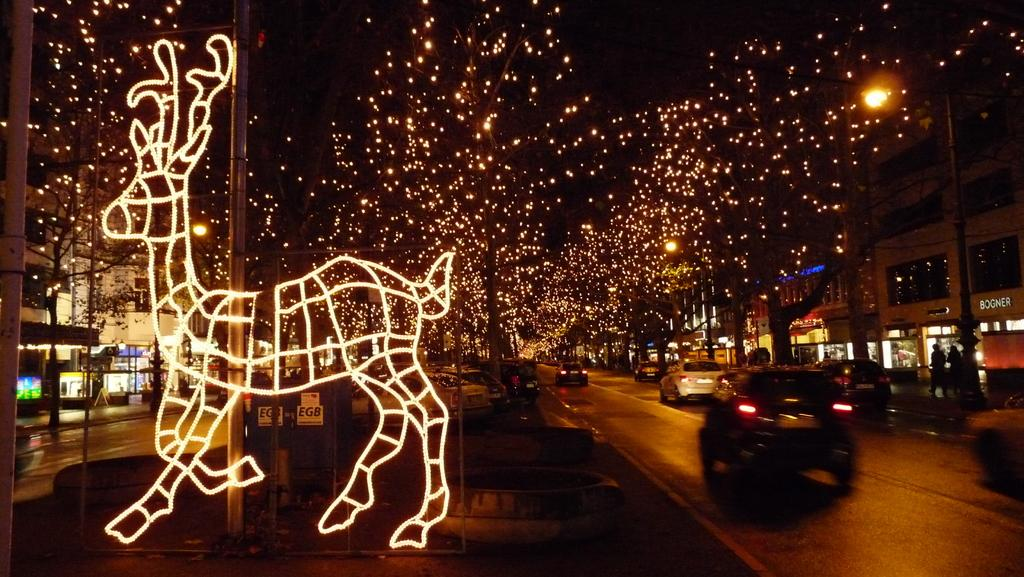What type of location is shown in the image? The image depicts a busy street. What can be seen on the street? Cars are riding on the road. What structures are visible in the background? There are buildings visible. How is the street decorated? The street is decorated with lights. What type of drug can be seen in the image? There is no drug present in the image. What kind of food is being sold on the street in the image? The image does not show any food being sold on the street. 